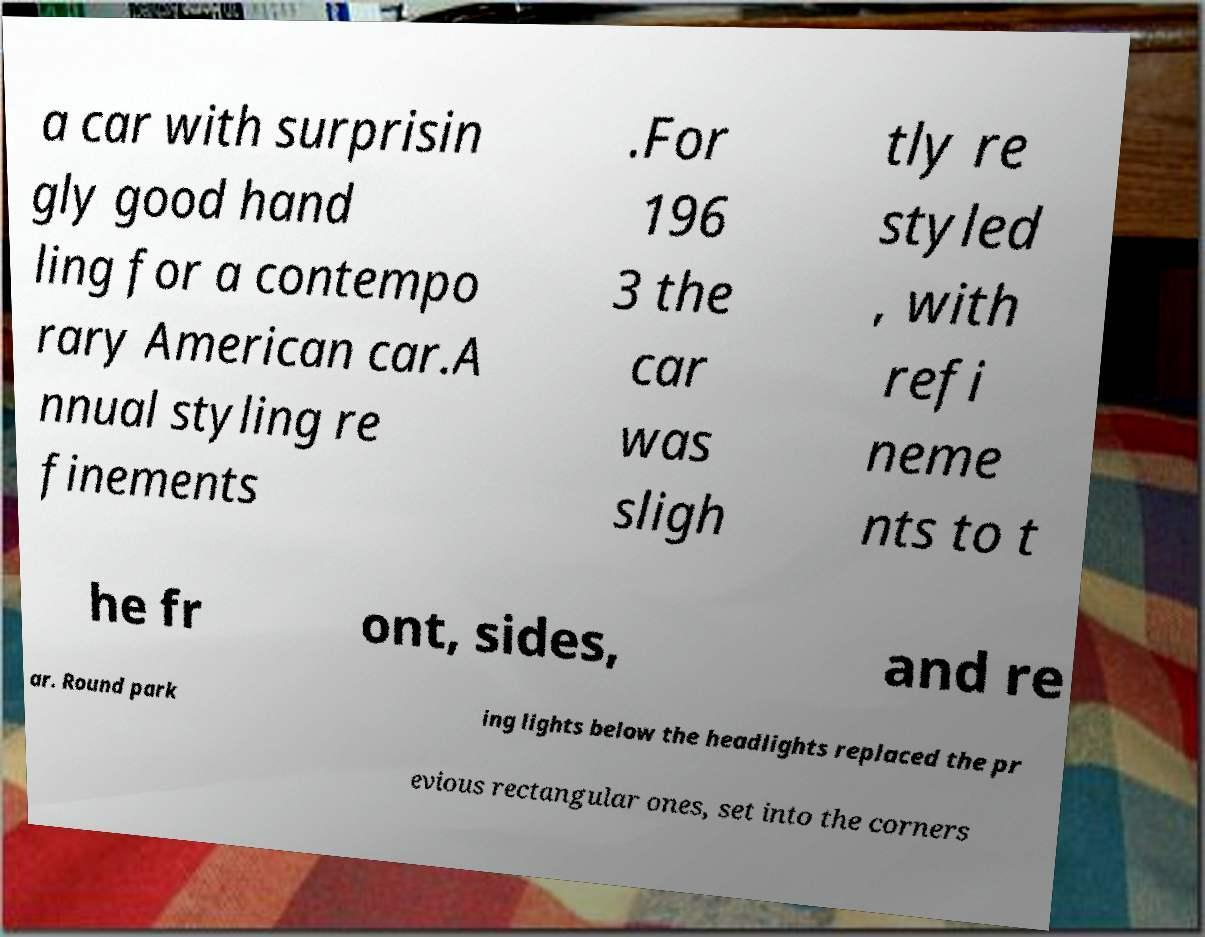There's text embedded in this image that I need extracted. Can you transcribe it verbatim? a car with surprisin gly good hand ling for a contempo rary American car.A nnual styling re finements .For 196 3 the car was sligh tly re styled , with refi neme nts to t he fr ont, sides, and re ar. Round park ing lights below the headlights replaced the pr evious rectangular ones, set into the corners 